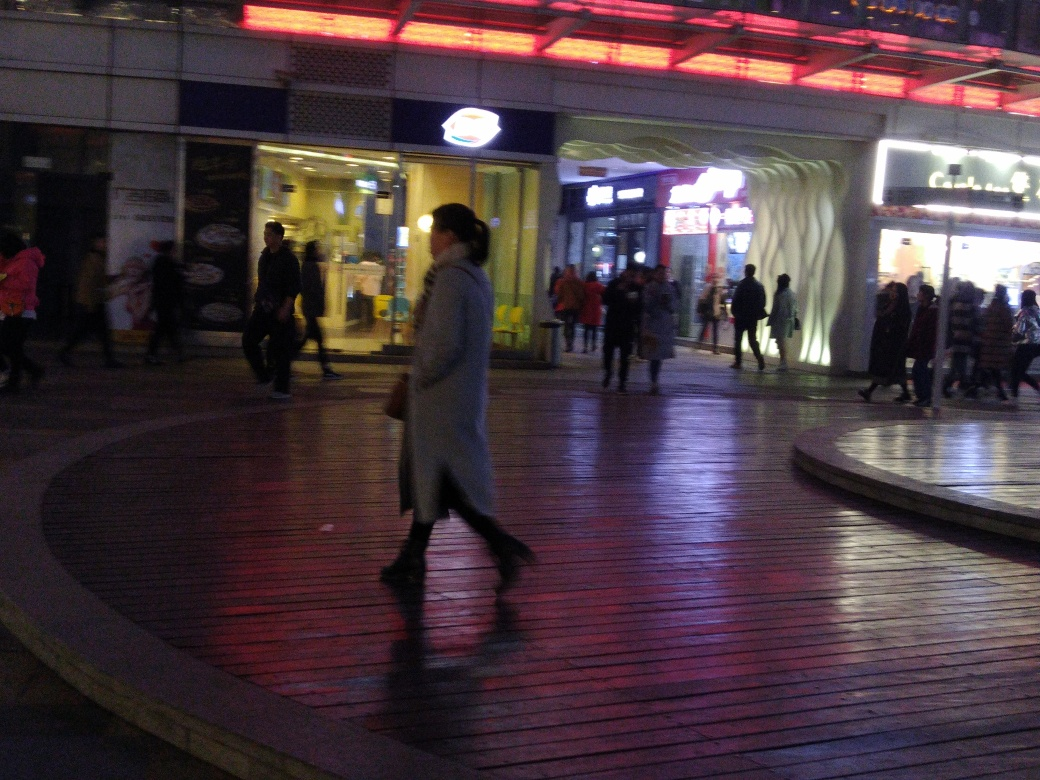What time of day does the image seem to represent, and how can you tell? The image appears to represent the evening or night time. This can be inferred from the artificial lighting, the long shadows cast by these lights, and the fact that the sky is dark. Furthermore, the attire of the pedestrians suggests colder weather, which could indicate a time closer to the night. 